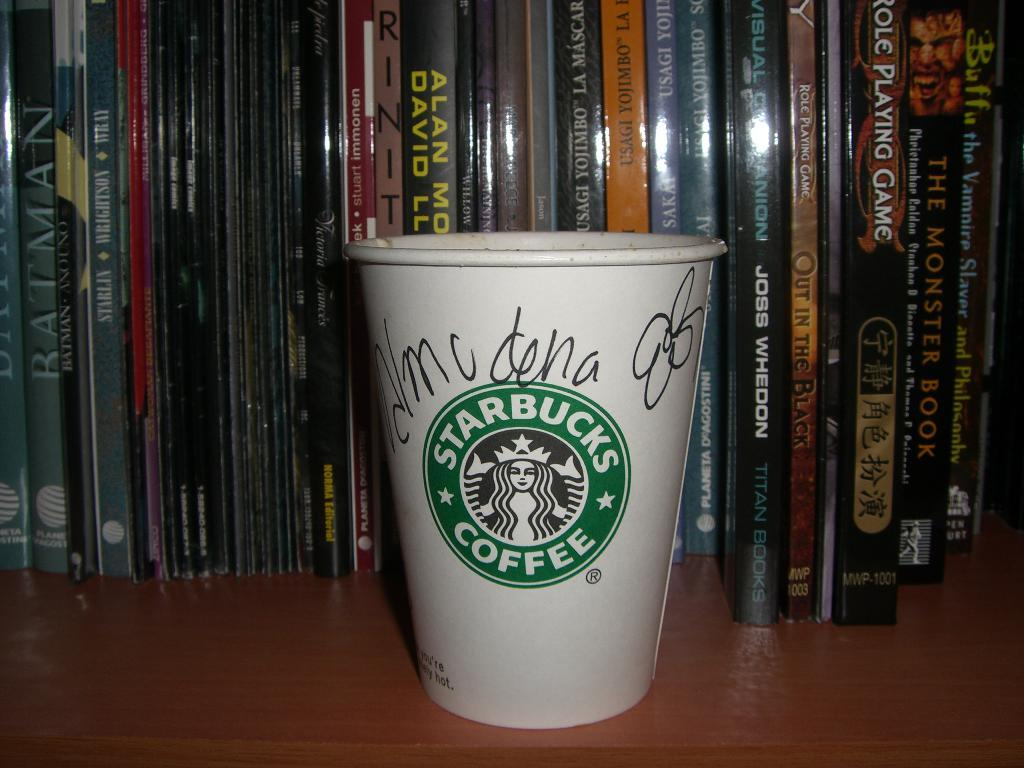<image>
Describe the image concisely. the word Starbucks is on the cup that is white 